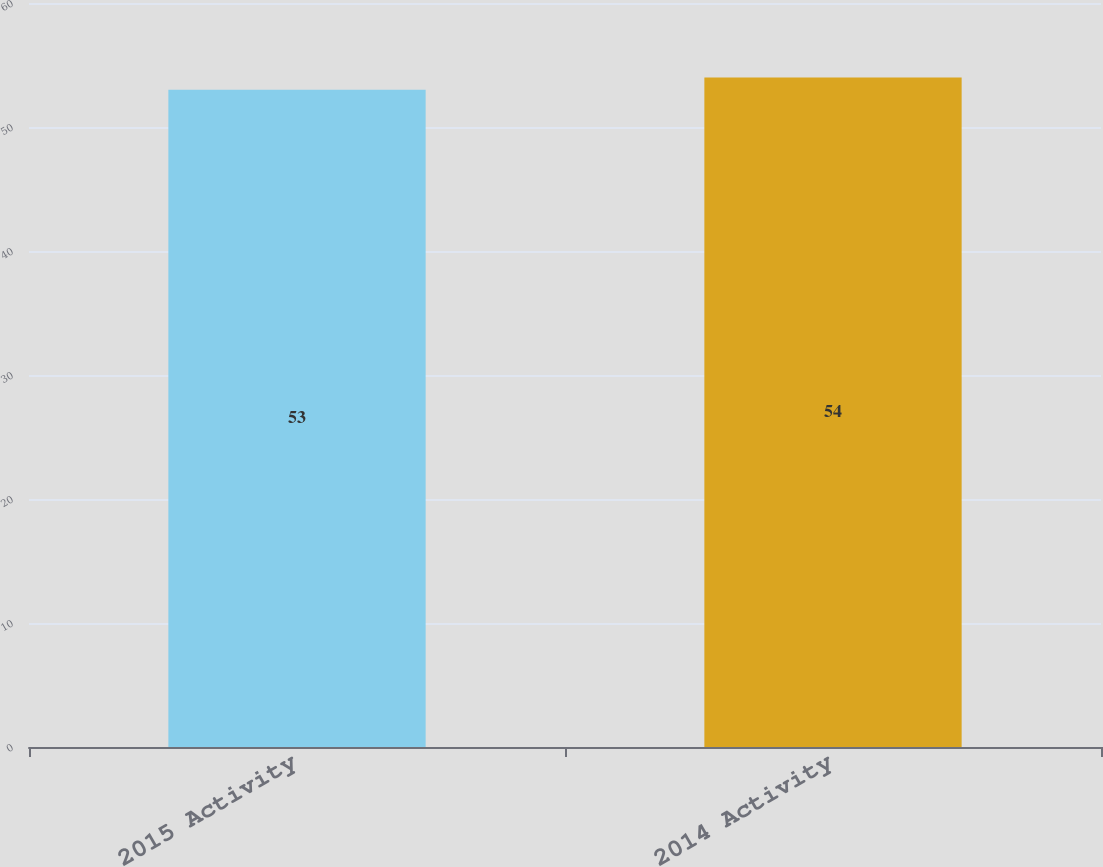<chart> <loc_0><loc_0><loc_500><loc_500><bar_chart><fcel>2015 Activity<fcel>2014 Activity<nl><fcel>53<fcel>54<nl></chart> 